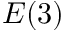<formula> <loc_0><loc_0><loc_500><loc_500>E ( 3 )</formula> 